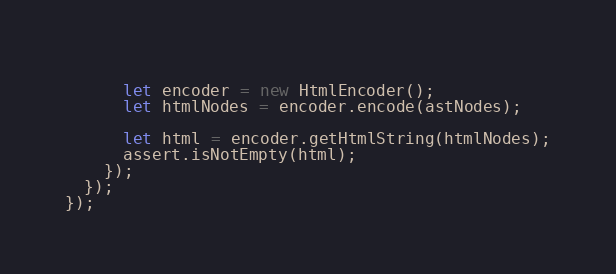Convert code to text. <code><loc_0><loc_0><loc_500><loc_500><_TypeScript_>      
      let encoder = new HtmlEncoder();
      let htmlNodes = encoder.encode(astNodes);

      let html = encoder.getHtmlString(htmlNodes);
      assert.isNotEmpty(html);
    });
  });
});</code> 